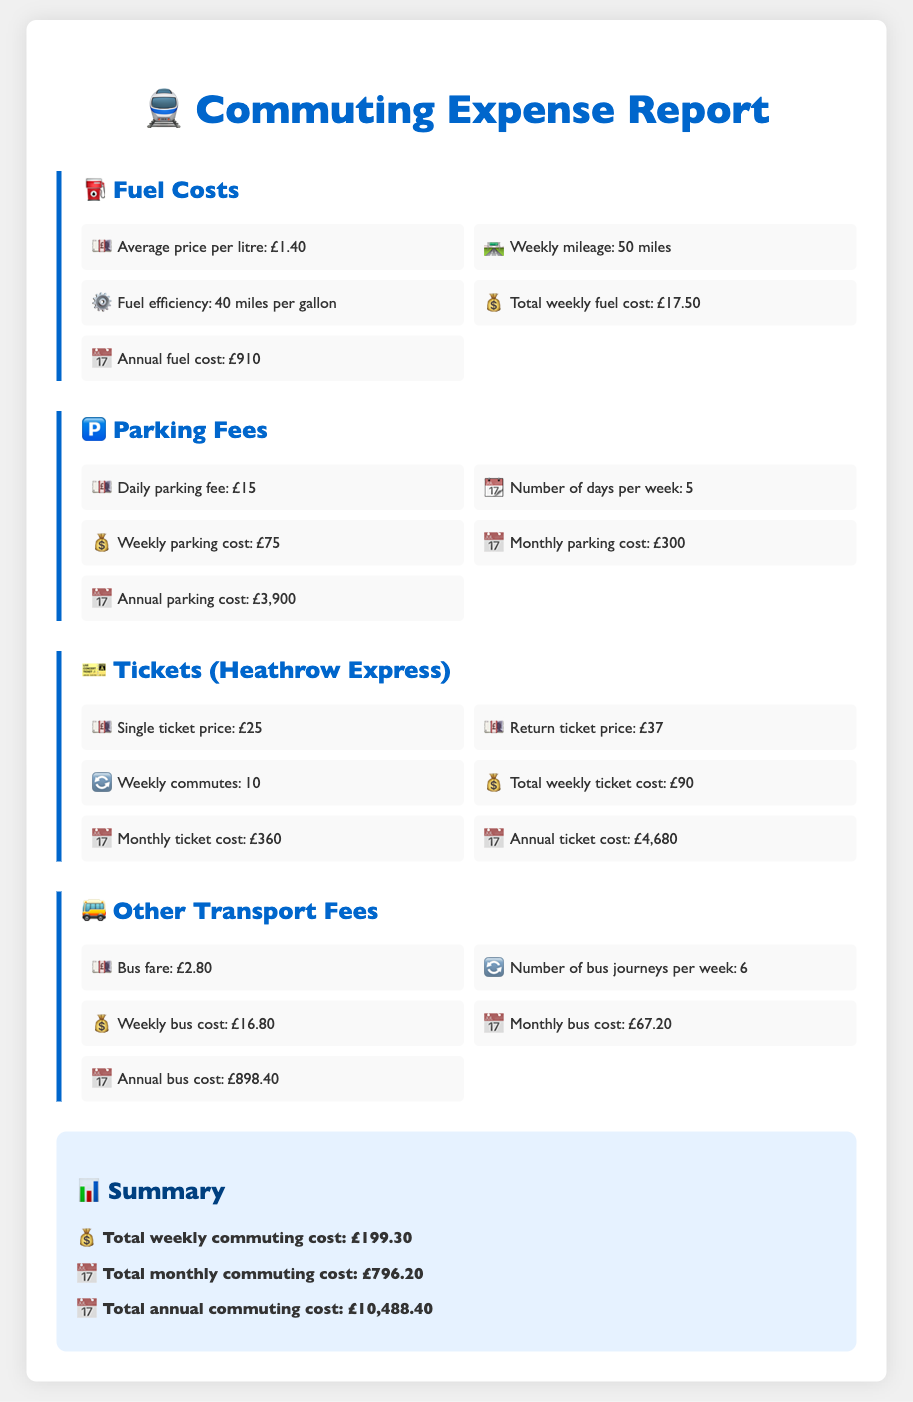What is the average price per litre of fuel? The average price per litre of fuel is listed in the document as £1.40.
Answer: £1.40 What is the total weekly parking cost? The total weekly parking cost is derived from the daily parking fee multiplied by the number of days per week, which is £15 * 5 = £75.
Answer: £75 How many weekly commutes are there for the Heathrow Express? The document states that there are 10 weekly commutes for the Heathrow Express.
Answer: 10 What is the monthly ticket cost for the Heathrow Express? The monthly ticket cost is explicitly stated in the document as £360.
Answer: £360 What is the total annual commuting cost? The total annual commuting cost is presented in the summary as £10,488.40.
Answer: £10,488.40 What is the weekly bus cost? The weekly bus cost is computed as the bus fare multiplied by the number of bus journeys per week, which totals £2.80 * 6 = £16.80.
Answer: £16.80 What is the fuel efficiency in miles per gallon? The fuel efficiency is noted as 40 miles per gallon in the document.
Answer: 40 miles per gallon What is the annual parking cost? The annual parking cost is directly provided in the document as £3,900.
Answer: £3,900 What is the total weekly commuting cost? The document sums up the total weekly commuting cost as £199.30.
Answer: £199.30 